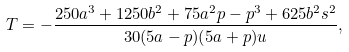<formula> <loc_0><loc_0><loc_500><loc_500>T = - \frac { 2 5 0 a ^ { 3 } + 1 2 5 0 b ^ { 2 } + 7 5 a ^ { 2 } p - p ^ { 3 } + 6 2 5 b ^ { 2 } s ^ { 2 } } { 3 0 ( 5 a - p ) ( 5 a + p ) u } ,</formula> 